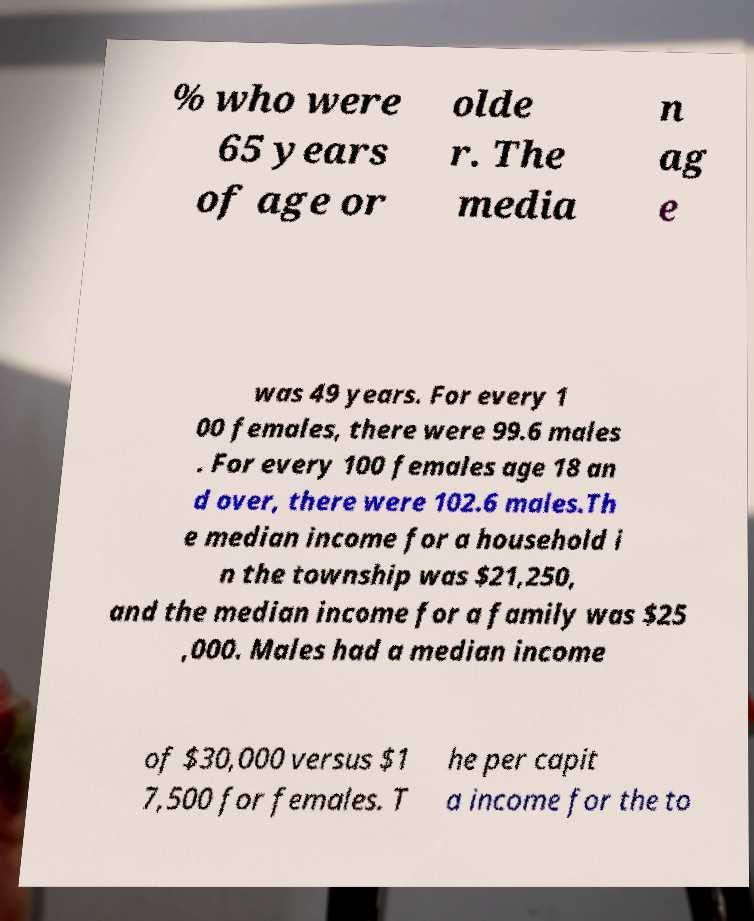Please identify and transcribe the text found in this image. % who were 65 years of age or olde r. The media n ag e was 49 years. For every 1 00 females, there were 99.6 males . For every 100 females age 18 an d over, there were 102.6 males.Th e median income for a household i n the township was $21,250, and the median income for a family was $25 ,000. Males had a median income of $30,000 versus $1 7,500 for females. T he per capit a income for the to 